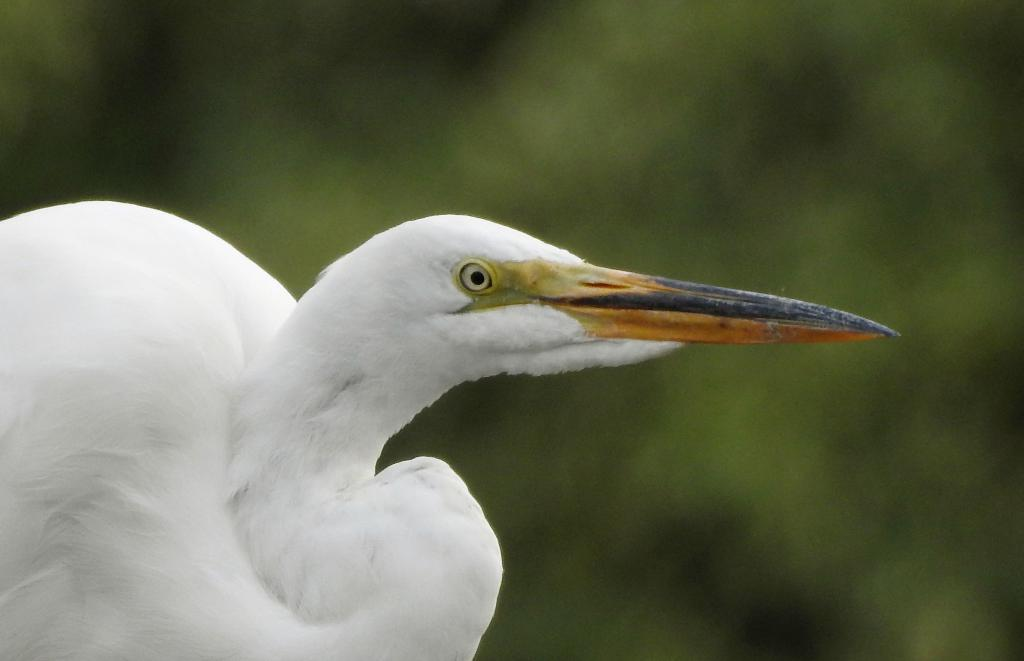What type of bird is in the image? There is a white egret bird in the image. How would you describe the quality of the image? The image is blurry in the background. What color can be seen in the background? There is green color visible in the background. How many quarters are visible in the image? There are no quarters present in the image. What type of plants can be seen in the image? The provided facts do not mention any plants in the image. 